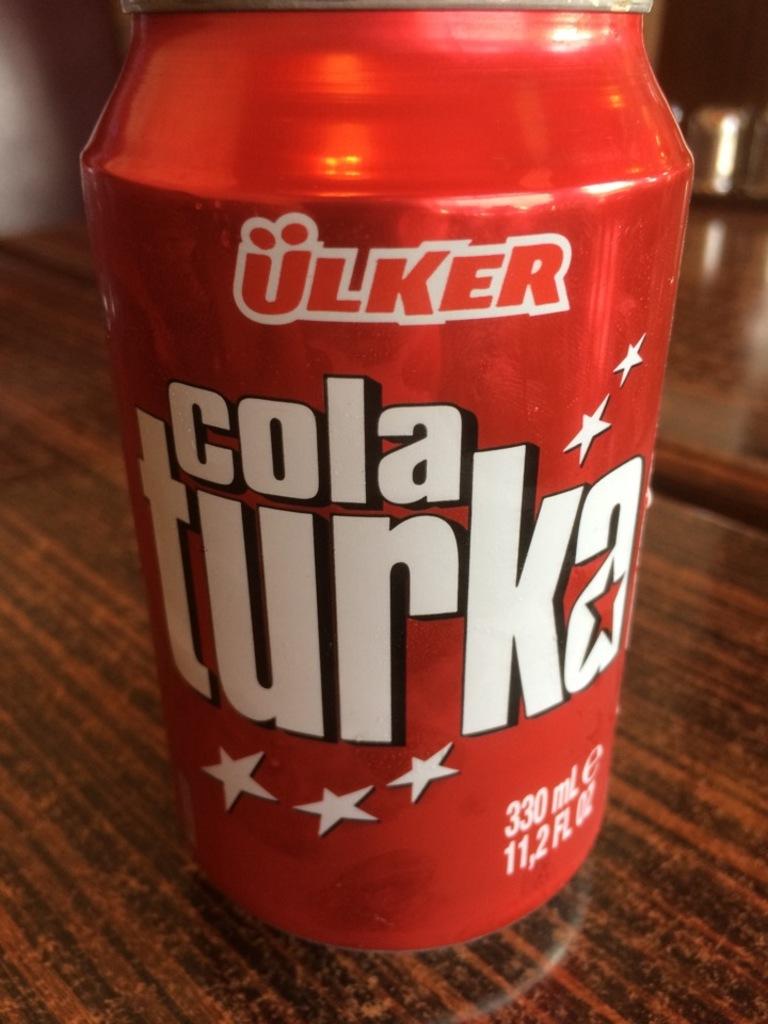What type of beverage is in the can?
Offer a terse response. Cola turka. How many ml of cola is in the can?
Offer a very short reply. 330. 